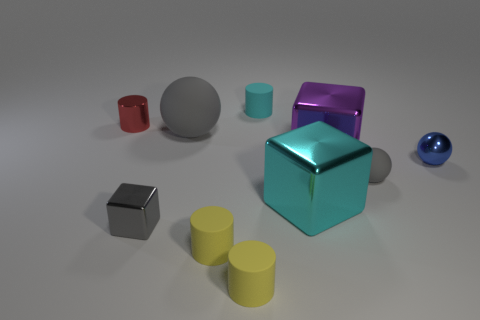Could you tell me which objects in the image have a reflective surface? Certainly! The objects with reflective surfaces in the image include the large teal cube positioned centrally, the medium-sized magenta cube, and the small silver cube. Their surfaces are smooth and mirror-like, reflecting the environment and the light, creating a visually interesting contrast with the matte-finish objects. 